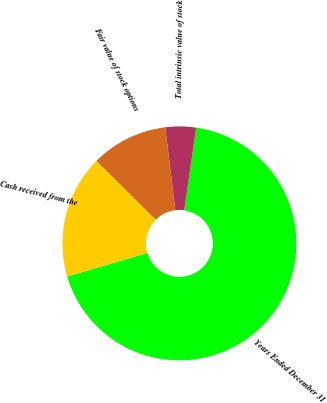<chart> <loc_0><loc_0><loc_500><loc_500><pie_chart><fcel>Years Ended December 31<fcel>Total intrinsic value of stock<fcel>Fair value of stock options<fcel>Cash received from the<nl><fcel>68.13%<fcel>4.23%<fcel>10.62%<fcel>17.01%<nl></chart> 